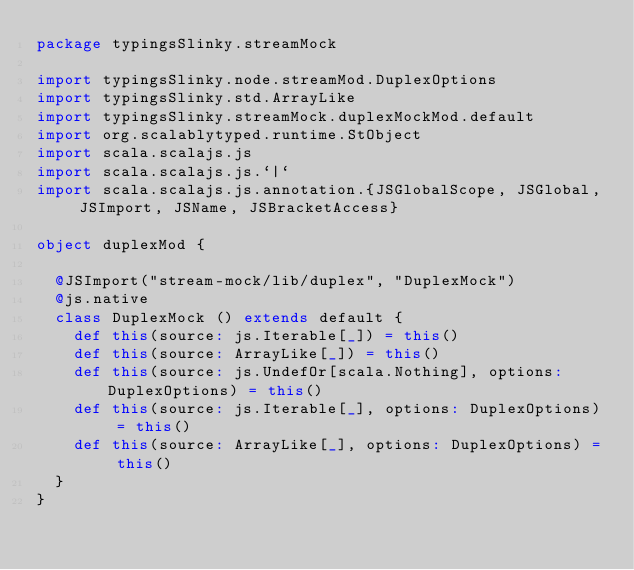<code> <loc_0><loc_0><loc_500><loc_500><_Scala_>package typingsSlinky.streamMock

import typingsSlinky.node.streamMod.DuplexOptions
import typingsSlinky.std.ArrayLike
import typingsSlinky.streamMock.duplexMockMod.default
import org.scalablytyped.runtime.StObject
import scala.scalajs.js
import scala.scalajs.js.`|`
import scala.scalajs.js.annotation.{JSGlobalScope, JSGlobal, JSImport, JSName, JSBracketAccess}

object duplexMod {
  
  @JSImport("stream-mock/lib/duplex", "DuplexMock")
  @js.native
  class DuplexMock () extends default {
    def this(source: js.Iterable[_]) = this()
    def this(source: ArrayLike[_]) = this()
    def this(source: js.UndefOr[scala.Nothing], options: DuplexOptions) = this()
    def this(source: js.Iterable[_], options: DuplexOptions) = this()
    def this(source: ArrayLike[_], options: DuplexOptions) = this()
  }
}
</code> 